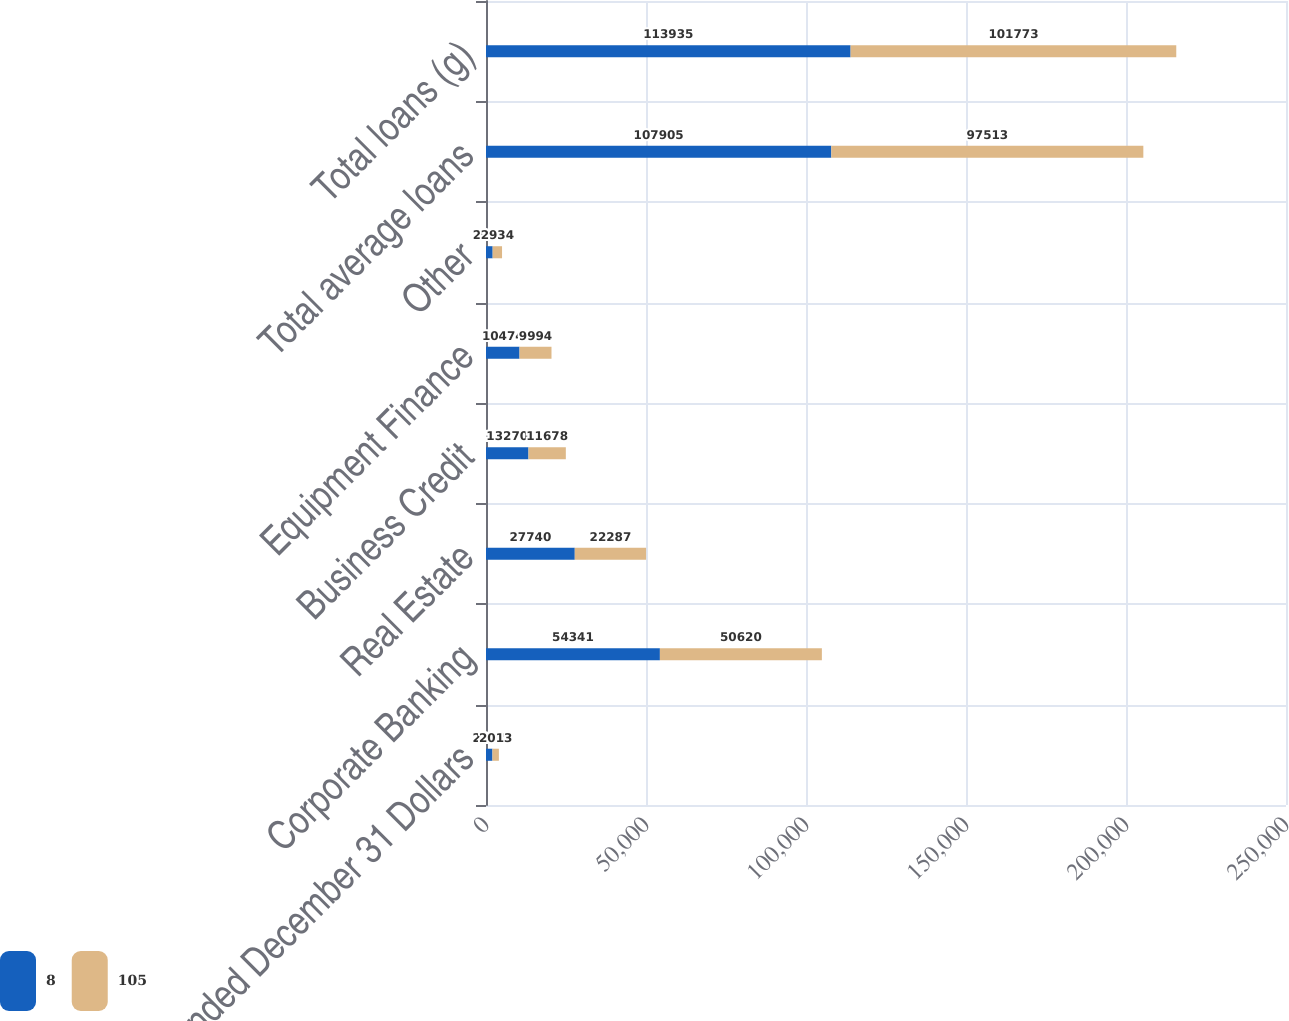Convert chart to OTSL. <chart><loc_0><loc_0><loc_500><loc_500><stacked_bar_chart><ecel><fcel>Year ended December 31 Dollars<fcel>Corporate Banking<fcel>Real Estate<fcel>Business Credit<fcel>Equipment Finance<fcel>Other<fcel>Total average loans<fcel>Total loans (g)<nl><fcel>8<fcel>2014<fcel>54341<fcel>27740<fcel>13270<fcel>10474<fcel>2080<fcel>107905<fcel>113935<nl><fcel>105<fcel>2013<fcel>50620<fcel>22287<fcel>11678<fcel>9994<fcel>2934<fcel>97513<fcel>101773<nl></chart> 